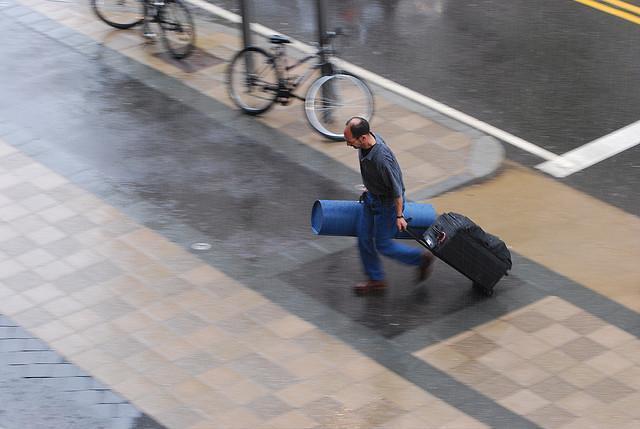What is the man transporting?
Make your selection from the four choices given to correctly answer the question.
Options: Luggage, pizza, bananas, eggs. Luggage. 